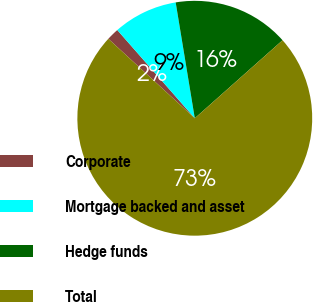Convert chart to OTSL. <chart><loc_0><loc_0><loc_500><loc_500><pie_chart><fcel>Corporate<fcel>Mortgage backed and asset<fcel>Hedge funds<fcel>Total<nl><fcel>1.7%<fcel>8.87%<fcel>16.04%<fcel>73.4%<nl></chart> 